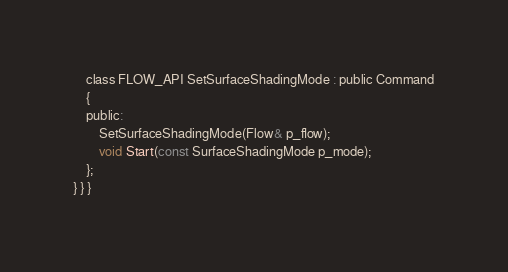<code> <loc_0><loc_0><loc_500><loc_500><_C_>
    class FLOW_API SetSurfaceShadingMode : public Command
    {
    public:
        SetSurfaceShadingMode(Flow& p_flow);
        void Start(const SurfaceShadingMode p_mode);
    };
} } }
</code> 